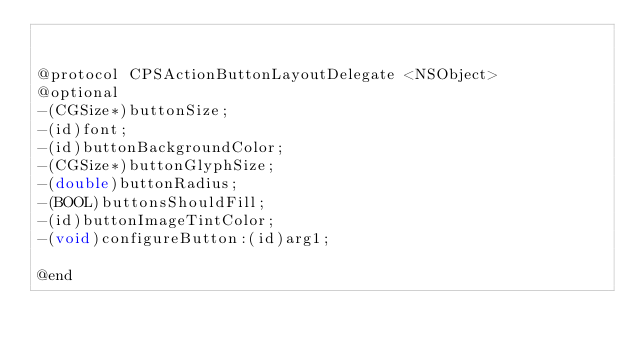Convert code to text. <code><loc_0><loc_0><loc_500><loc_500><_C_>

@protocol CPSActionButtonLayoutDelegate <NSObject>
@optional
-(CGSize*)buttonSize;
-(id)font;
-(id)buttonBackgroundColor;
-(CGSize*)buttonGlyphSize;
-(double)buttonRadius;
-(BOOL)buttonsShouldFill;
-(id)buttonImageTintColor;
-(void)configureButton:(id)arg1;

@end

</code> 